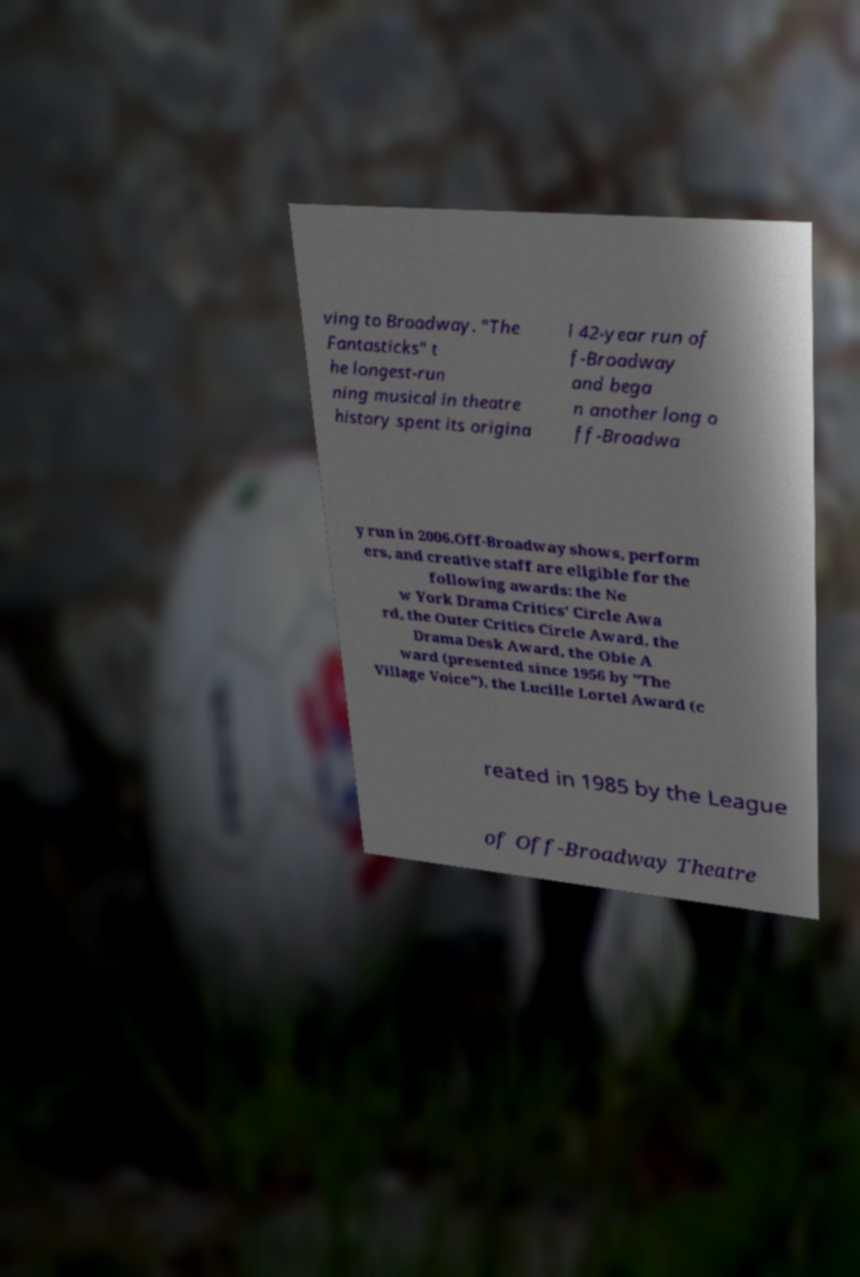Please identify and transcribe the text found in this image. ving to Broadway. "The Fantasticks" t he longest-run ning musical in theatre history spent its origina l 42-year run of f-Broadway and bega n another long o ff-Broadwa y run in 2006.Off-Broadway shows, perform ers, and creative staff are eligible for the following awards: the Ne w York Drama Critics' Circle Awa rd, the Outer Critics Circle Award, the Drama Desk Award, the Obie A ward (presented since 1956 by "The Village Voice"), the Lucille Lortel Award (c reated in 1985 by the League of Off-Broadway Theatre 